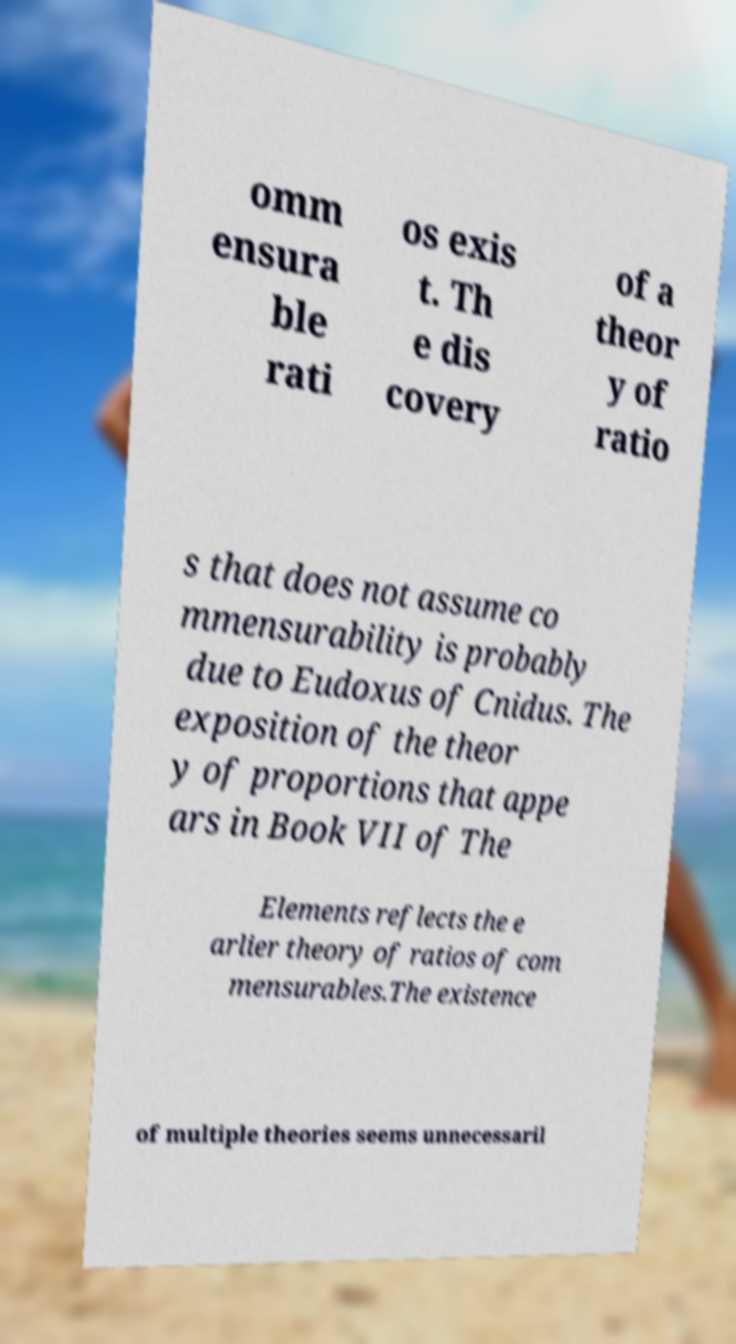Please read and relay the text visible in this image. What does it say? omm ensura ble rati os exis t. Th e dis covery of a theor y of ratio s that does not assume co mmensurability is probably due to Eudoxus of Cnidus. The exposition of the theor y of proportions that appe ars in Book VII of The Elements reflects the e arlier theory of ratios of com mensurables.The existence of multiple theories seems unnecessaril 